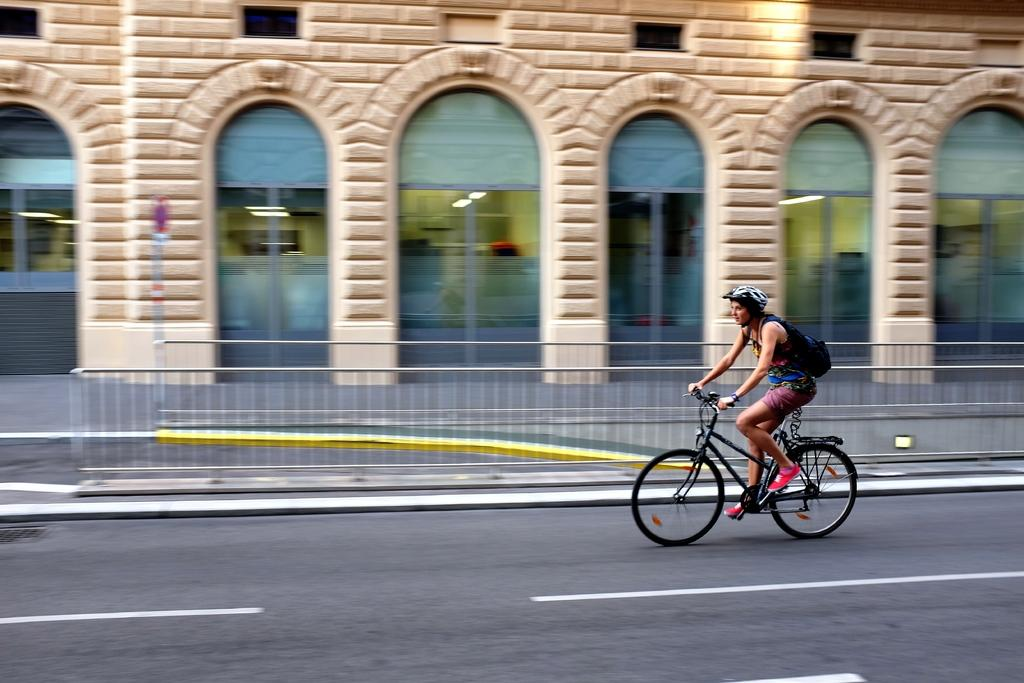Who is the main subject in the image? There is a woman in the image. What is the woman wearing that might be related to safety? The woman is wearing a helmet. What is the woman doing in the image? The woman is riding a bicycle. Where is the bicycle located? The bicycle is on the road. What can be seen in the background of the image? There is a building in the image, and there is a light in the building. What type of exchange is taking place between the woman and the car in the image? There is no car present in the image; the woman is riding a bicycle on the road. What part of the woman's body is visible in the image? The image only shows the woman from the waist up, so it is not possible to determine which parts of her body are visible. 